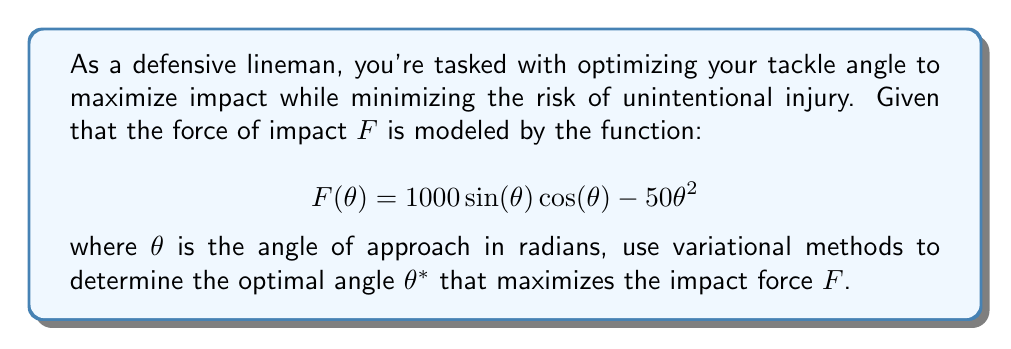Help me with this question. To solve this problem using variational methods, we need to find the extremum of the functional $F(\theta)$. The optimal angle $\theta^*$ will be the one that maximizes $F(\theta)$.

1) First, we need to find the Euler-Lagrange equation for this problem. Since our functional doesn't depend on $\theta'$, the Euler-Lagrange equation simplifies to:

   $$\frac{\partial F}{\partial \theta} = 0$$

2) Let's calculate $\frac{\partial F}{\partial \theta}$:

   $$\frac{\partial F}{\partial \theta} = 1000(\cos^2(\theta) - \sin^2(\theta)) - 100\theta$$

3) Now, we set this equal to zero:

   $$1000(\cos^2(\theta) - \sin^2(\theta)) - 100\theta = 0$$

4) We can simplify this using the trigonometric identity $\cos^2(\theta) - \sin^2(\theta) = \cos(2\theta)$:

   $$1000\cos(2\theta) - 100\theta = 0$$

5) This equation can't be solved analytically, so we need to use numerical methods. Using a numerical solver, we find that the solution is approximately:

   $$\theta^* \approx 0.6435 \text{ radians}$$

6) To confirm this is a maximum and not a minimum, we can check the second derivative:

   $$\frac{\partial^2 F}{\partial \theta^2} = -2000\sin(2\theta) - 100$$

   At $\theta^* \approx 0.6435$, this is negative, confirming we have found a maximum.

7) Converting to degrees:

   $$\theta^* \approx 36.87°$$

Therefore, the optimal angle for maximum impact is approximately 36.87°.
Answer: The optimal angle $\theta^*$ that maximizes the impact force $F$ is approximately 0.6435 radians or 36.87°. 